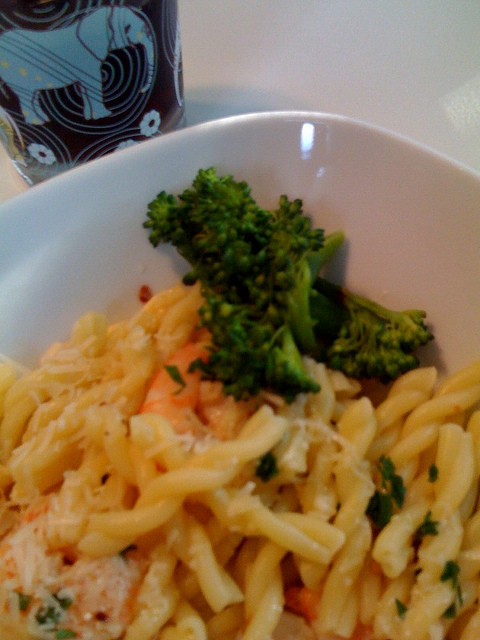<image>What kind of pasta is used in the dish? I don't know the exact type of pasta used in the dish. It could be fusilli, macaroni, tortellini, or rotini. What kind of pasta is used in the dish? I am not sure what kind of pasta is used in the dish. It could be curly noodles, twist, tortellini, spiral, macaroni, fusilli, or rotini. 